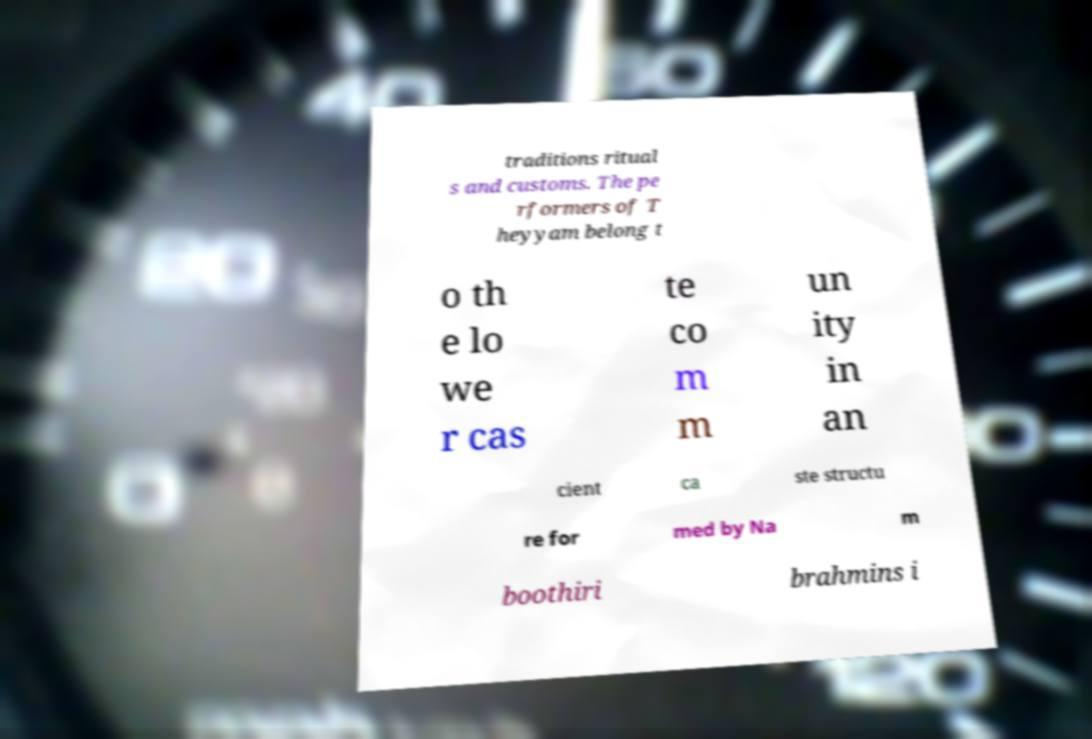Can you read and provide the text displayed in the image?This photo seems to have some interesting text. Can you extract and type it out for me? traditions ritual s and customs. The pe rformers of T heyyam belong t o th e lo we r cas te co m m un ity in an cient ca ste structu re for med by Na m boothiri brahmins i 